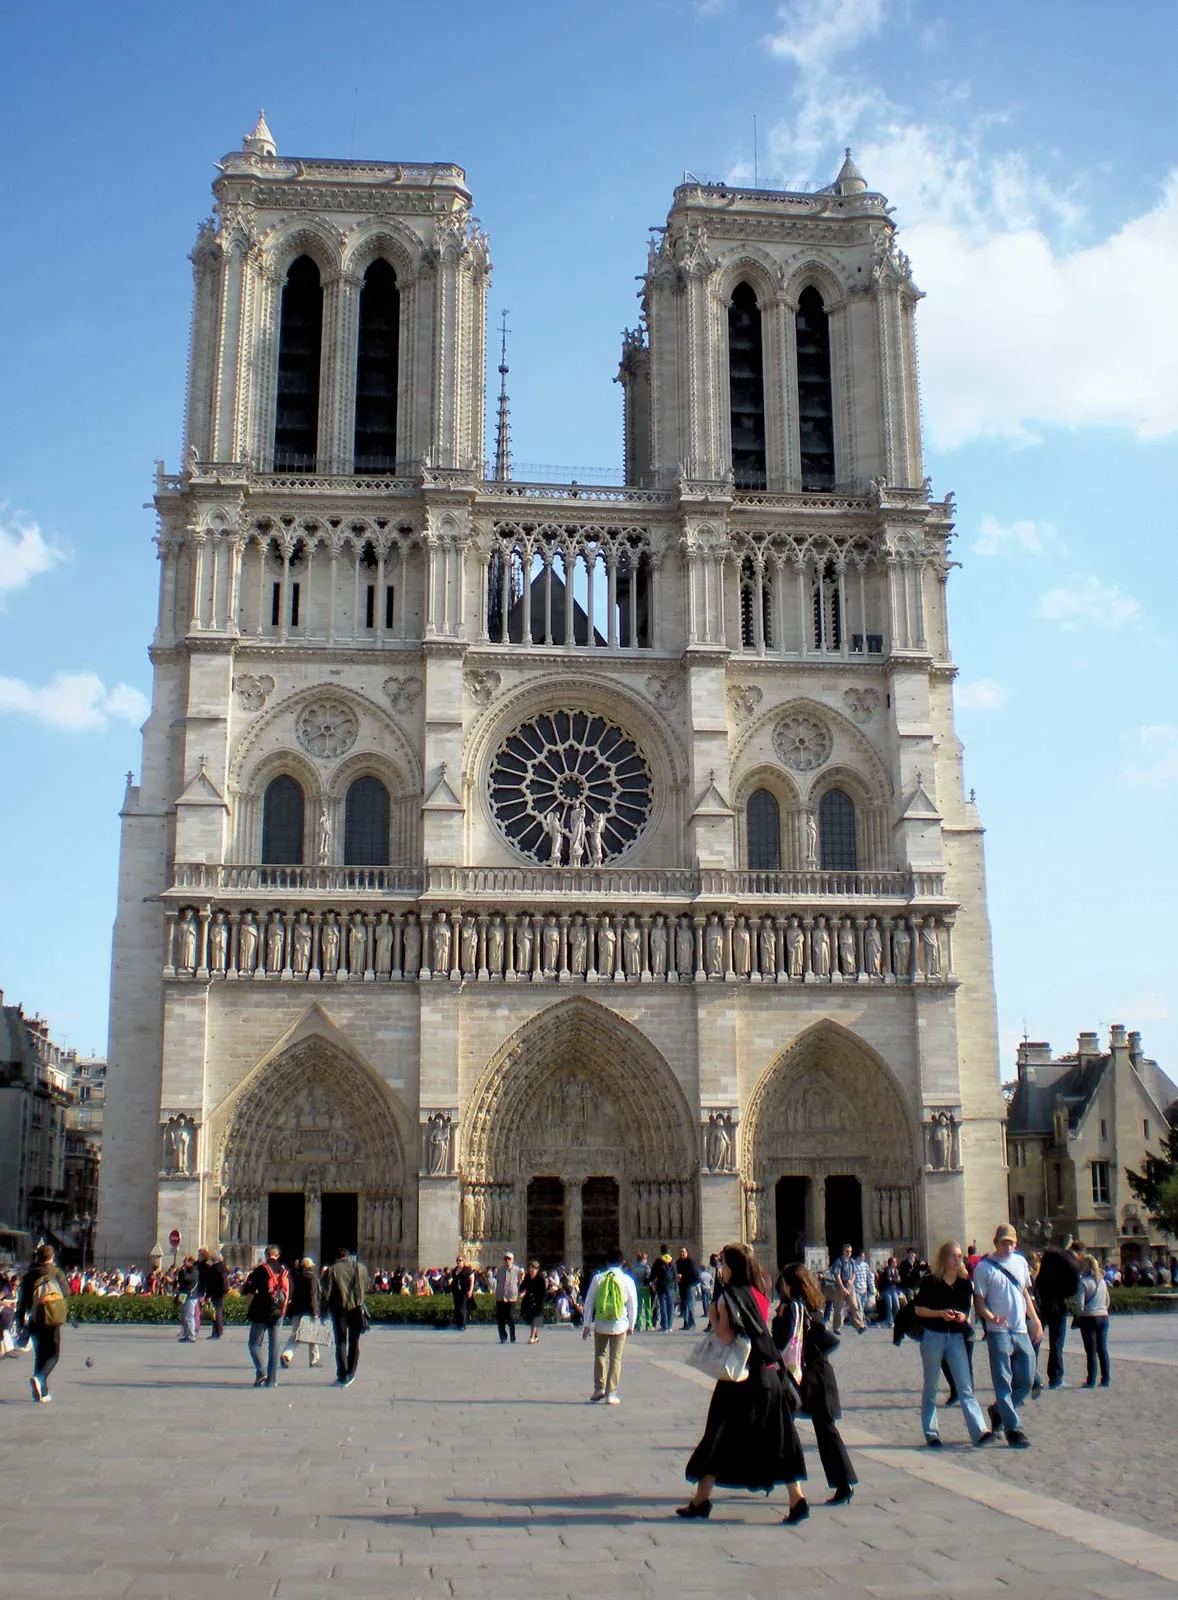Write a detailed description of the given image. The image portrays the magnificent Notre Dame Cathedral, a globally recognized monument situated in Paris, France. Seen from a frontal view, the cathedral's prominent architectural features, including its two soaring towers and the intricately designed rose window, are clearly visible against a backdrop of a pristine blue sky. The facade brims with historical significance, adorned with detailed sculptures and mythical gargoyles that typify the Gothic architectural style. In the foreground, a lively scene unfolds as people traverse the open plaza, adding a vibrant human element to the setting. The photograph not only captures the grandeur of Notre Dame’s structure but also the everyday interactions of visitors who come to admire this historic edifice. 